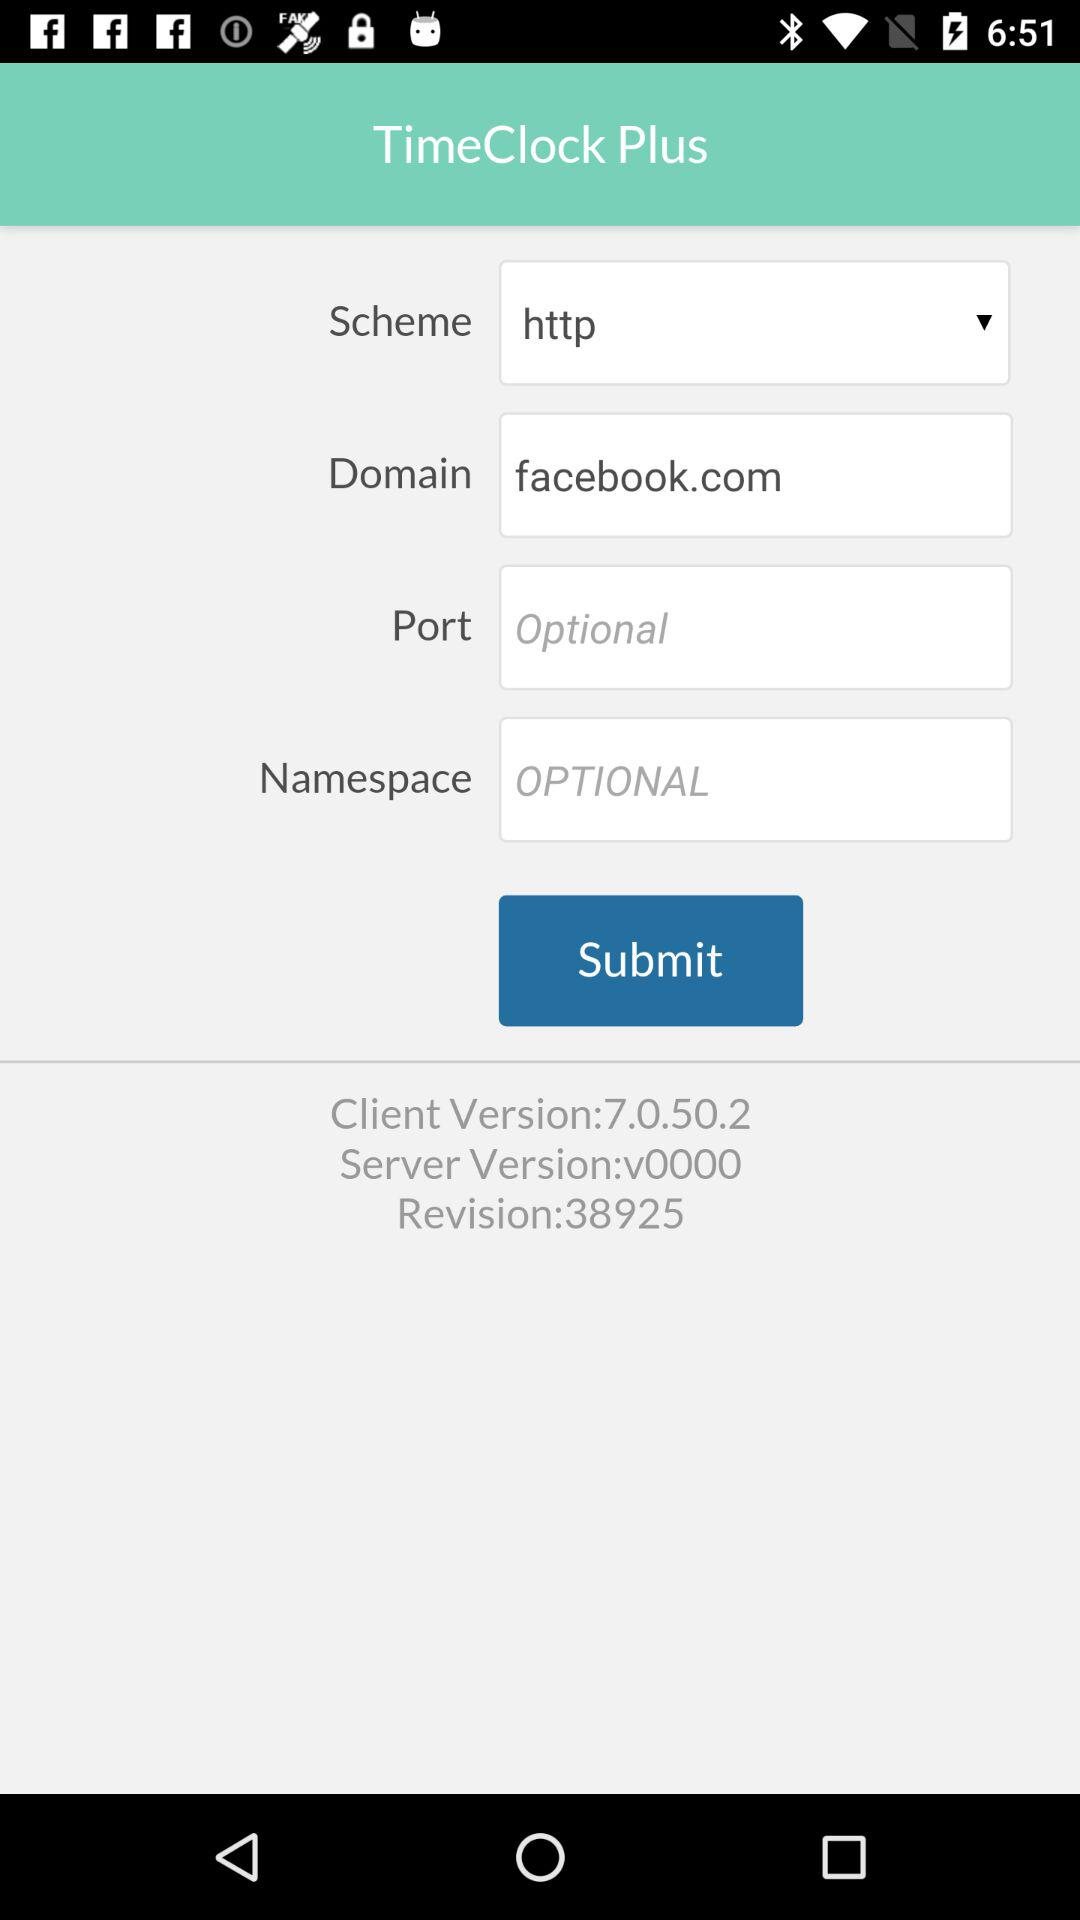What is the client version? The client version is 7.0.50.2. 